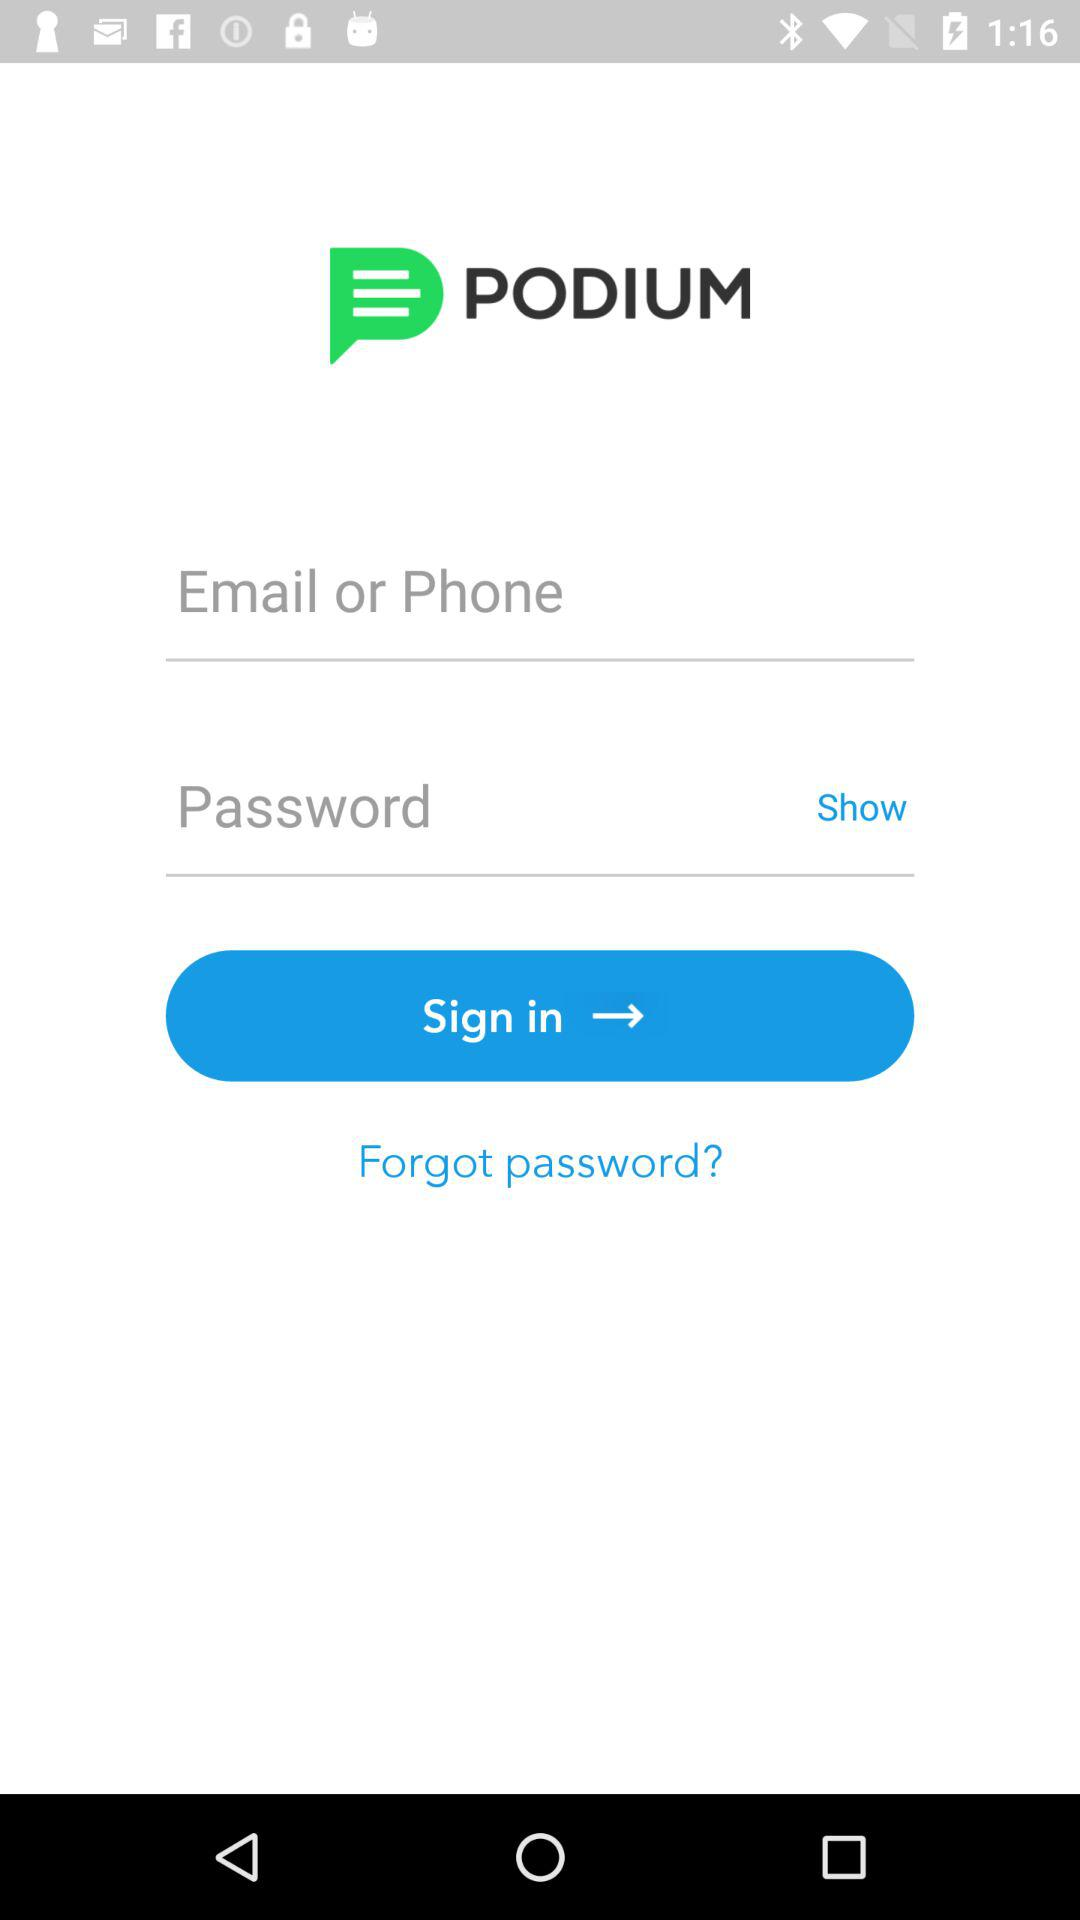What is the name of the application? The application name is "PODIUM". 